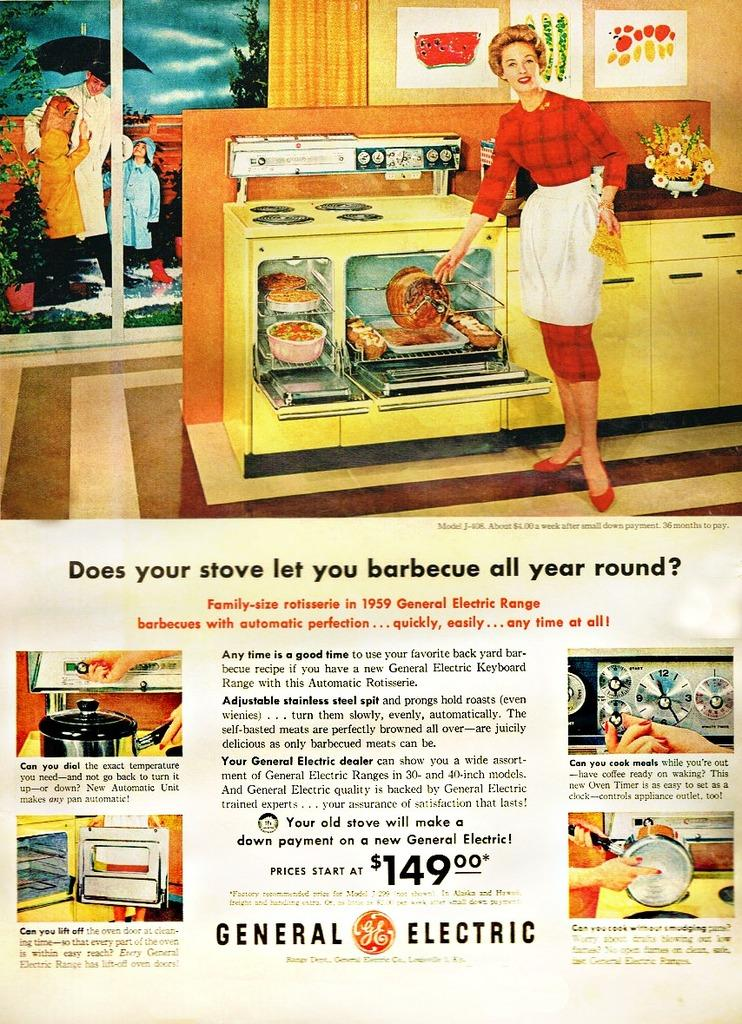<image>
Render a clear and concise summary of the photo. a 149.00 ad for some kind of appliance 